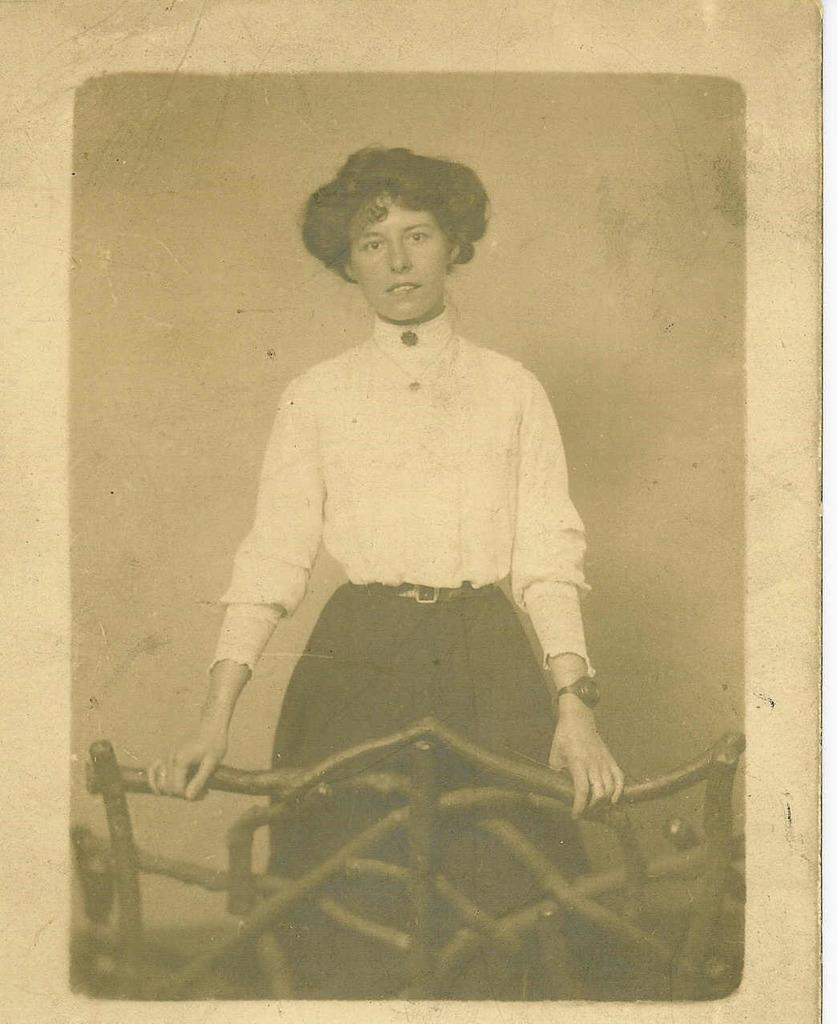Who is the main subject in the image? There is a woman in the image. What is the woman doing in the image? The woman is standing behind a railing. What type of clothing is the woman wearing? The woman is wearing a shirt and a skirt. What is the color scheme of the image? The image is black and white. What position does the woman hold in the image? The image does not indicate any specific position or role that the woman holds. Can you see a swing in the image? There is no swing present in the image. 